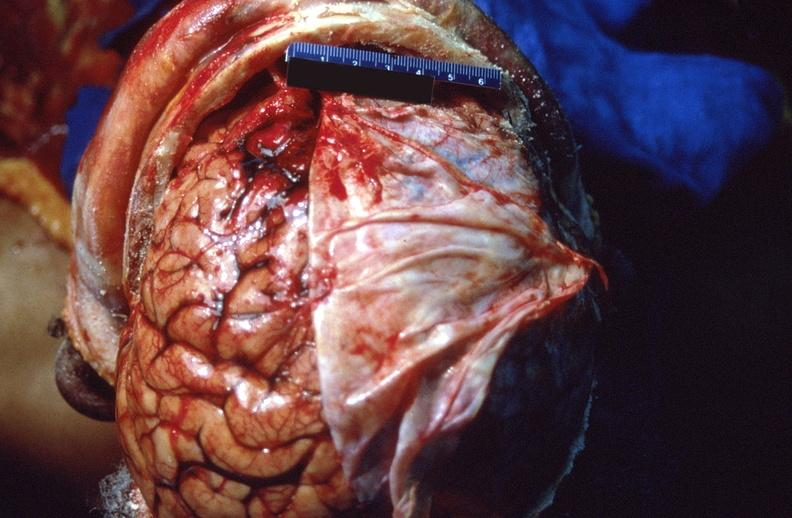does metastatic carcinoma show brain, intracerebral hemorrhage?
Answer the question using a single word or phrase. No 